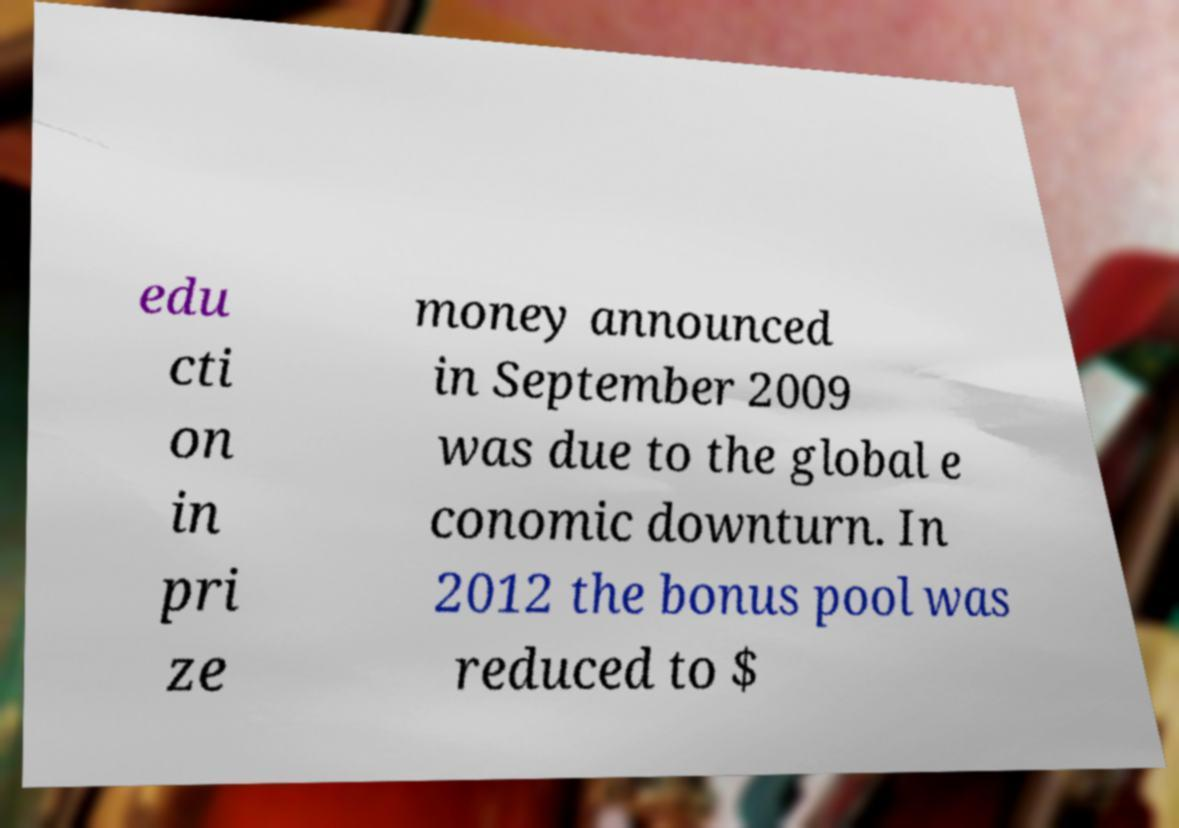What messages or text are displayed in this image? I need them in a readable, typed format. edu cti on in pri ze money announced in September 2009 was due to the global e conomic downturn. In 2012 the bonus pool was reduced to $ 